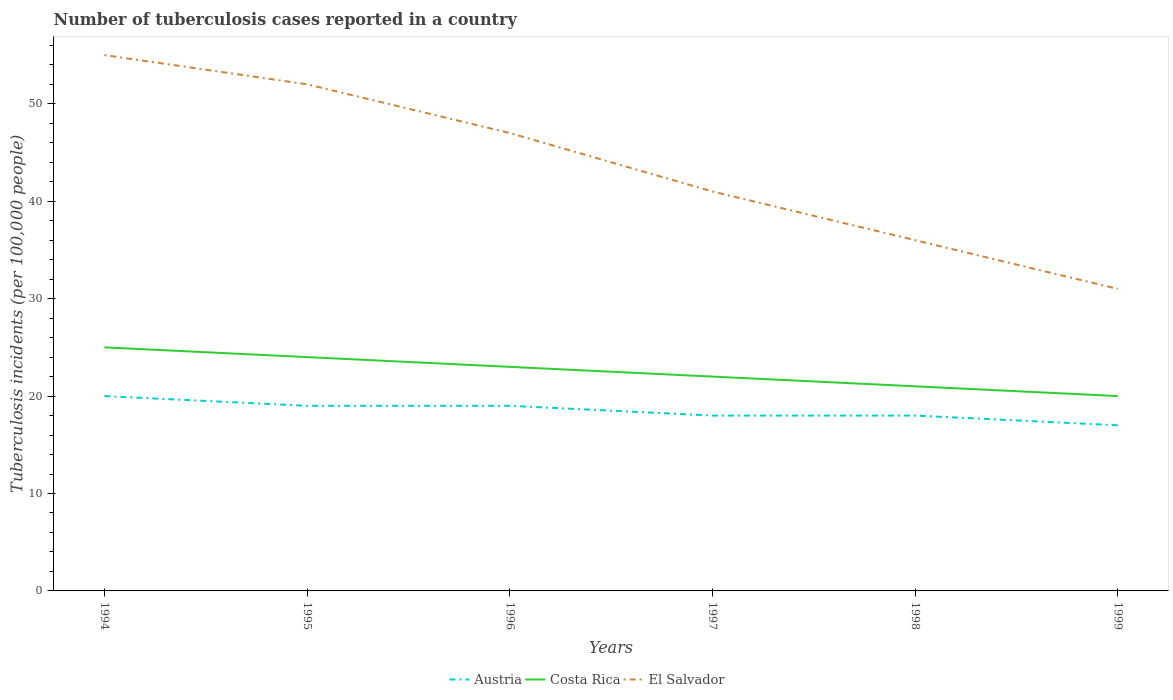How many different coloured lines are there?
Provide a short and direct response. 3. Across all years, what is the maximum number of tuberculosis cases reported in in Costa Rica?
Give a very brief answer. 20. What is the total number of tuberculosis cases reported in in Costa Rica in the graph?
Give a very brief answer. 2. What is the difference between the highest and the second highest number of tuberculosis cases reported in in El Salvador?
Provide a short and direct response. 24. Is the number of tuberculosis cases reported in in Costa Rica strictly greater than the number of tuberculosis cases reported in in Austria over the years?
Keep it short and to the point. No. How many lines are there?
Provide a short and direct response. 3. What is the difference between two consecutive major ticks on the Y-axis?
Your answer should be compact. 10. Does the graph contain grids?
Make the answer very short. No. How are the legend labels stacked?
Give a very brief answer. Horizontal. What is the title of the graph?
Provide a short and direct response. Number of tuberculosis cases reported in a country. Does "Syrian Arab Republic" appear as one of the legend labels in the graph?
Offer a very short reply. No. What is the label or title of the X-axis?
Offer a terse response. Years. What is the label or title of the Y-axis?
Offer a very short reply. Tuberculosis incidents (per 100,0 people). What is the Tuberculosis incidents (per 100,000 people) in Costa Rica in 1994?
Provide a short and direct response. 25. What is the Tuberculosis incidents (per 100,000 people) in El Salvador in 1994?
Offer a terse response. 55. What is the Tuberculosis incidents (per 100,000 people) in El Salvador in 1995?
Your answer should be compact. 52. What is the Tuberculosis incidents (per 100,000 people) in Costa Rica in 1996?
Your response must be concise. 23. What is the Tuberculosis incidents (per 100,000 people) of Austria in 1998?
Your response must be concise. 18. Across all years, what is the maximum Tuberculosis incidents (per 100,000 people) of Austria?
Provide a short and direct response. 20. Across all years, what is the maximum Tuberculosis incidents (per 100,000 people) in Costa Rica?
Make the answer very short. 25. Across all years, what is the maximum Tuberculosis incidents (per 100,000 people) in El Salvador?
Provide a succinct answer. 55. Across all years, what is the minimum Tuberculosis incidents (per 100,000 people) in El Salvador?
Give a very brief answer. 31. What is the total Tuberculosis incidents (per 100,000 people) in Austria in the graph?
Your response must be concise. 111. What is the total Tuberculosis incidents (per 100,000 people) of Costa Rica in the graph?
Ensure brevity in your answer.  135. What is the total Tuberculosis incidents (per 100,000 people) of El Salvador in the graph?
Provide a short and direct response. 262. What is the difference between the Tuberculosis incidents (per 100,000 people) of Austria in 1994 and that in 1995?
Your answer should be compact. 1. What is the difference between the Tuberculosis incidents (per 100,000 people) of Costa Rica in 1994 and that in 1995?
Keep it short and to the point. 1. What is the difference between the Tuberculosis incidents (per 100,000 people) in Costa Rica in 1994 and that in 1997?
Offer a very short reply. 3. What is the difference between the Tuberculosis incidents (per 100,000 people) in El Salvador in 1994 and that in 1997?
Offer a terse response. 14. What is the difference between the Tuberculosis incidents (per 100,000 people) in Austria in 1994 and that in 1999?
Give a very brief answer. 3. What is the difference between the Tuberculosis incidents (per 100,000 people) in El Salvador in 1994 and that in 1999?
Make the answer very short. 24. What is the difference between the Tuberculosis incidents (per 100,000 people) of Costa Rica in 1995 and that in 1997?
Ensure brevity in your answer.  2. What is the difference between the Tuberculosis incidents (per 100,000 people) in Austria in 1995 and that in 1998?
Offer a very short reply. 1. What is the difference between the Tuberculosis incidents (per 100,000 people) of Costa Rica in 1995 and that in 1998?
Your response must be concise. 3. What is the difference between the Tuberculosis incidents (per 100,000 people) in Costa Rica in 1995 and that in 1999?
Your response must be concise. 4. What is the difference between the Tuberculosis incidents (per 100,000 people) of Austria in 1996 and that in 1997?
Keep it short and to the point. 1. What is the difference between the Tuberculosis incidents (per 100,000 people) of Costa Rica in 1996 and that in 1997?
Make the answer very short. 1. What is the difference between the Tuberculosis incidents (per 100,000 people) of El Salvador in 1996 and that in 1997?
Make the answer very short. 6. What is the difference between the Tuberculosis incidents (per 100,000 people) in Austria in 1996 and that in 1998?
Keep it short and to the point. 1. What is the difference between the Tuberculosis incidents (per 100,000 people) of Costa Rica in 1996 and that in 1998?
Ensure brevity in your answer.  2. What is the difference between the Tuberculosis incidents (per 100,000 people) of El Salvador in 1996 and that in 1998?
Offer a terse response. 11. What is the difference between the Tuberculosis incidents (per 100,000 people) in Austria in 1996 and that in 1999?
Keep it short and to the point. 2. What is the difference between the Tuberculosis incidents (per 100,000 people) of El Salvador in 1996 and that in 1999?
Offer a very short reply. 16. What is the difference between the Tuberculosis incidents (per 100,000 people) of Austria in 1997 and that in 1998?
Offer a terse response. 0. What is the difference between the Tuberculosis incidents (per 100,000 people) in El Salvador in 1997 and that in 1998?
Keep it short and to the point. 5. What is the difference between the Tuberculosis incidents (per 100,000 people) of Austria in 1997 and that in 1999?
Your response must be concise. 1. What is the difference between the Tuberculosis incidents (per 100,000 people) of Costa Rica in 1997 and that in 1999?
Your response must be concise. 2. What is the difference between the Tuberculosis incidents (per 100,000 people) of Costa Rica in 1998 and that in 1999?
Your answer should be very brief. 1. What is the difference between the Tuberculosis incidents (per 100,000 people) of Austria in 1994 and the Tuberculosis incidents (per 100,000 people) of Costa Rica in 1995?
Provide a succinct answer. -4. What is the difference between the Tuberculosis incidents (per 100,000 people) in Austria in 1994 and the Tuberculosis incidents (per 100,000 people) in El Salvador in 1995?
Your answer should be very brief. -32. What is the difference between the Tuberculosis incidents (per 100,000 people) in Costa Rica in 1994 and the Tuberculosis incidents (per 100,000 people) in El Salvador in 1995?
Offer a very short reply. -27. What is the difference between the Tuberculosis incidents (per 100,000 people) of Austria in 1994 and the Tuberculosis incidents (per 100,000 people) of Costa Rica in 1997?
Your answer should be compact. -2. What is the difference between the Tuberculosis incidents (per 100,000 people) of Costa Rica in 1994 and the Tuberculosis incidents (per 100,000 people) of El Salvador in 1997?
Give a very brief answer. -16. What is the difference between the Tuberculosis incidents (per 100,000 people) in Austria in 1994 and the Tuberculosis incidents (per 100,000 people) in Costa Rica in 1998?
Make the answer very short. -1. What is the difference between the Tuberculosis incidents (per 100,000 people) in Austria in 1994 and the Tuberculosis incidents (per 100,000 people) in Costa Rica in 1999?
Keep it short and to the point. 0. What is the difference between the Tuberculosis incidents (per 100,000 people) of Austria in 1994 and the Tuberculosis incidents (per 100,000 people) of El Salvador in 1999?
Offer a very short reply. -11. What is the difference between the Tuberculosis incidents (per 100,000 people) in Costa Rica in 1994 and the Tuberculosis incidents (per 100,000 people) in El Salvador in 1999?
Your response must be concise. -6. What is the difference between the Tuberculosis incidents (per 100,000 people) of Austria in 1995 and the Tuberculosis incidents (per 100,000 people) of El Salvador in 1996?
Your response must be concise. -28. What is the difference between the Tuberculosis incidents (per 100,000 people) in Costa Rica in 1995 and the Tuberculosis incidents (per 100,000 people) in El Salvador in 1996?
Offer a very short reply. -23. What is the difference between the Tuberculosis incidents (per 100,000 people) of Austria in 1995 and the Tuberculosis incidents (per 100,000 people) of Costa Rica in 1997?
Offer a terse response. -3. What is the difference between the Tuberculosis incidents (per 100,000 people) of Austria in 1995 and the Tuberculosis incidents (per 100,000 people) of El Salvador in 1997?
Offer a very short reply. -22. What is the difference between the Tuberculosis incidents (per 100,000 people) in Austria in 1995 and the Tuberculosis incidents (per 100,000 people) in El Salvador in 1998?
Provide a succinct answer. -17. What is the difference between the Tuberculosis incidents (per 100,000 people) of Costa Rica in 1995 and the Tuberculosis incidents (per 100,000 people) of El Salvador in 1999?
Your response must be concise. -7. What is the difference between the Tuberculosis incidents (per 100,000 people) in Austria in 1996 and the Tuberculosis incidents (per 100,000 people) in El Salvador in 1997?
Give a very brief answer. -22. What is the difference between the Tuberculosis incidents (per 100,000 people) of Austria in 1996 and the Tuberculosis incidents (per 100,000 people) of Costa Rica in 1998?
Provide a short and direct response. -2. What is the difference between the Tuberculosis incidents (per 100,000 people) in Costa Rica in 1996 and the Tuberculosis incidents (per 100,000 people) in El Salvador in 1998?
Keep it short and to the point. -13. What is the difference between the Tuberculosis incidents (per 100,000 people) in Austria in 1996 and the Tuberculosis incidents (per 100,000 people) in El Salvador in 1999?
Offer a very short reply. -12. What is the difference between the Tuberculosis incidents (per 100,000 people) in Costa Rica in 1996 and the Tuberculosis incidents (per 100,000 people) in El Salvador in 1999?
Make the answer very short. -8. What is the difference between the Tuberculosis incidents (per 100,000 people) of Austria in 1997 and the Tuberculosis incidents (per 100,000 people) of El Salvador in 1998?
Provide a short and direct response. -18. What is the difference between the Tuberculosis incidents (per 100,000 people) in Costa Rica in 1997 and the Tuberculosis incidents (per 100,000 people) in El Salvador in 1999?
Provide a short and direct response. -9. What is the difference between the Tuberculosis incidents (per 100,000 people) in Austria in 1998 and the Tuberculosis incidents (per 100,000 people) in Costa Rica in 1999?
Provide a short and direct response. -2. What is the average Tuberculosis incidents (per 100,000 people) of Austria per year?
Provide a short and direct response. 18.5. What is the average Tuberculosis incidents (per 100,000 people) in El Salvador per year?
Your response must be concise. 43.67. In the year 1994, what is the difference between the Tuberculosis incidents (per 100,000 people) of Austria and Tuberculosis incidents (per 100,000 people) of El Salvador?
Keep it short and to the point. -35. In the year 1994, what is the difference between the Tuberculosis incidents (per 100,000 people) in Costa Rica and Tuberculosis incidents (per 100,000 people) in El Salvador?
Offer a very short reply. -30. In the year 1995, what is the difference between the Tuberculosis incidents (per 100,000 people) of Austria and Tuberculosis incidents (per 100,000 people) of Costa Rica?
Your answer should be very brief. -5. In the year 1995, what is the difference between the Tuberculosis incidents (per 100,000 people) of Austria and Tuberculosis incidents (per 100,000 people) of El Salvador?
Ensure brevity in your answer.  -33. In the year 1995, what is the difference between the Tuberculosis incidents (per 100,000 people) in Costa Rica and Tuberculosis incidents (per 100,000 people) in El Salvador?
Your answer should be very brief. -28. In the year 1996, what is the difference between the Tuberculosis incidents (per 100,000 people) of Austria and Tuberculosis incidents (per 100,000 people) of Costa Rica?
Ensure brevity in your answer.  -4. In the year 1996, what is the difference between the Tuberculosis incidents (per 100,000 people) in Austria and Tuberculosis incidents (per 100,000 people) in El Salvador?
Make the answer very short. -28. In the year 1996, what is the difference between the Tuberculosis incidents (per 100,000 people) of Costa Rica and Tuberculosis incidents (per 100,000 people) of El Salvador?
Offer a very short reply. -24. In the year 1997, what is the difference between the Tuberculosis incidents (per 100,000 people) of Austria and Tuberculosis incidents (per 100,000 people) of El Salvador?
Your response must be concise. -23. In the year 1997, what is the difference between the Tuberculosis incidents (per 100,000 people) of Costa Rica and Tuberculosis incidents (per 100,000 people) of El Salvador?
Make the answer very short. -19. In the year 1998, what is the difference between the Tuberculosis incidents (per 100,000 people) of Austria and Tuberculosis incidents (per 100,000 people) of Costa Rica?
Give a very brief answer. -3. In the year 1998, what is the difference between the Tuberculosis incidents (per 100,000 people) in Costa Rica and Tuberculosis incidents (per 100,000 people) in El Salvador?
Offer a terse response. -15. In the year 1999, what is the difference between the Tuberculosis incidents (per 100,000 people) of Austria and Tuberculosis incidents (per 100,000 people) of El Salvador?
Offer a very short reply. -14. What is the ratio of the Tuberculosis incidents (per 100,000 people) in Austria in 1994 to that in 1995?
Offer a terse response. 1.05. What is the ratio of the Tuberculosis incidents (per 100,000 people) in Costa Rica in 1994 to that in 1995?
Your response must be concise. 1.04. What is the ratio of the Tuberculosis incidents (per 100,000 people) in El Salvador in 1994 to that in 1995?
Offer a terse response. 1.06. What is the ratio of the Tuberculosis incidents (per 100,000 people) in Austria in 1994 to that in 1996?
Provide a short and direct response. 1.05. What is the ratio of the Tuberculosis incidents (per 100,000 people) in Costa Rica in 1994 to that in 1996?
Provide a short and direct response. 1.09. What is the ratio of the Tuberculosis incidents (per 100,000 people) of El Salvador in 1994 to that in 1996?
Give a very brief answer. 1.17. What is the ratio of the Tuberculosis incidents (per 100,000 people) in Austria in 1994 to that in 1997?
Provide a short and direct response. 1.11. What is the ratio of the Tuberculosis incidents (per 100,000 people) of Costa Rica in 1994 to that in 1997?
Your answer should be compact. 1.14. What is the ratio of the Tuberculosis incidents (per 100,000 people) of El Salvador in 1994 to that in 1997?
Make the answer very short. 1.34. What is the ratio of the Tuberculosis incidents (per 100,000 people) in Costa Rica in 1994 to that in 1998?
Make the answer very short. 1.19. What is the ratio of the Tuberculosis incidents (per 100,000 people) of El Salvador in 1994 to that in 1998?
Your answer should be very brief. 1.53. What is the ratio of the Tuberculosis incidents (per 100,000 people) in Austria in 1994 to that in 1999?
Your response must be concise. 1.18. What is the ratio of the Tuberculosis incidents (per 100,000 people) in El Salvador in 1994 to that in 1999?
Offer a terse response. 1.77. What is the ratio of the Tuberculosis incidents (per 100,000 people) in Austria in 1995 to that in 1996?
Provide a succinct answer. 1. What is the ratio of the Tuberculosis incidents (per 100,000 people) in Costa Rica in 1995 to that in 1996?
Provide a short and direct response. 1.04. What is the ratio of the Tuberculosis incidents (per 100,000 people) of El Salvador in 1995 to that in 1996?
Make the answer very short. 1.11. What is the ratio of the Tuberculosis incidents (per 100,000 people) in Austria in 1995 to that in 1997?
Make the answer very short. 1.06. What is the ratio of the Tuberculosis incidents (per 100,000 people) of Costa Rica in 1995 to that in 1997?
Offer a terse response. 1.09. What is the ratio of the Tuberculosis incidents (per 100,000 people) in El Salvador in 1995 to that in 1997?
Your response must be concise. 1.27. What is the ratio of the Tuberculosis incidents (per 100,000 people) in Austria in 1995 to that in 1998?
Offer a very short reply. 1.06. What is the ratio of the Tuberculosis incidents (per 100,000 people) of Costa Rica in 1995 to that in 1998?
Offer a very short reply. 1.14. What is the ratio of the Tuberculosis incidents (per 100,000 people) in El Salvador in 1995 to that in 1998?
Keep it short and to the point. 1.44. What is the ratio of the Tuberculosis incidents (per 100,000 people) in Austria in 1995 to that in 1999?
Your answer should be very brief. 1.12. What is the ratio of the Tuberculosis incidents (per 100,000 people) of El Salvador in 1995 to that in 1999?
Ensure brevity in your answer.  1.68. What is the ratio of the Tuberculosis incidents (per 100,000 people) of Austria in 1996 to that in 1997?
Make the answer very short. 1.06. What is the ratio of the Tuberculosis incidents (per 100,000 people) in Costa Rica in 1996 to that in 1997?
Offer a terse response. 1.05. What is the ratio of the Tuberculosis incidents (per 100,000 people) of El Salvador in 1996 to that in 1997?
Provide a succinct answer. 1.15. What is the ratio of the Tuberculosis incidents (per 100,000 people) in Austria in 1996 to that in 1998?
Provide a short and direct response. 1.06. What is the ratio of the Tuberculosis incidents (per 100,000 people) of Costa Rica in 1996 to that in 1998?
Your answer should be compact. 1.1. What is the ratio of the Tuberculosis incidents (per 100,000 people) of El Salvador in 1996 to that in 1998?
Ensure brevity in your answer.  1.31. What is the ratio of the Tuberculosis incidents (per 100,000 people) of Austria in 1996 to that in 1999?
Give a very brief answer. 1.12. What is the ratio of the Tuberculosis incidents (per 100,000 people) in Costa Rica in 1996 to that in 1999?
Ensure brevity in your answer.  1.15. What is the ratio of the Tuberculosis incidents (per 100,000 people) in El Salvador in 1996 to that in 1999?
Provide a short and direct response. 1.52. What is the ratio of the Tuberculosis incidents (per 100,000 people) of Costa Rica in 1997 to that in 1998?
Keep it short and to the point. 1.05. What is the ratio of the Tuberculosis incidents (per 100,000 people) in El Salvador in 1997 to that in 1998?
Offer a very short reply. 1.14. What is the ratio of the Tuberculosis incidents (per 100,000 people) of Austria in 1997 to that in 1999?
Keep it short and to the point. 1.06. What is the ratio of the Tuberculosis incidents (per 100,000 people) in Costa Rica in 1997 to that in 1999?
Provide a short and direct response. 1.1. What is the ratio of the Tuberculosis incidents (per 100,000 people) in El Salvador in 1997 to that in 1999?
Your answer should be compact. 1.32. What is the ratio of the Tuberculosis incidents (per 100,000 people) of Austria in 1998 to that in 1999?
Your response must be concise. 1.06. What is the ratio of the Tuberculosis incidents (per 100,000 people) of Costa Rica in 1998 to that in 1999?
Keep it short and to the point. 1.05. What is the ratio of the Tuberculosis incidents (per 100,000 people) in El Salvador in 1998 to that in 1999?
Ensure brevity in your answer.  1.16. What is the difference between the highest and the second highest Tuberculosis incidents (per 100,000 people) of Austria?
Give a very brief answer. 1. What is the difference between the highest and the second highest Tuberculosis incidents (per 100,000 people) in El Salvador?
Provide a short and direct response. 3. What is the difference between the highest and the lowest Tuberculosis incidents (per 100,000 people) in Austria?
Give a very brief answer. 3. What is the difference between the highest and the lowest Tuberculosis incidents (per 100,000 people) in El Salvador?
Your answer should be very brief. 24. 